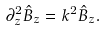Convert formula to latex. <formula><loc_0><loc_0><loc_500><loc_500>\partial ^ { 2 } _ { z } \hat { B } _ { z } = k ^ { 2 } \hat { B } _ { z } .</formula> 